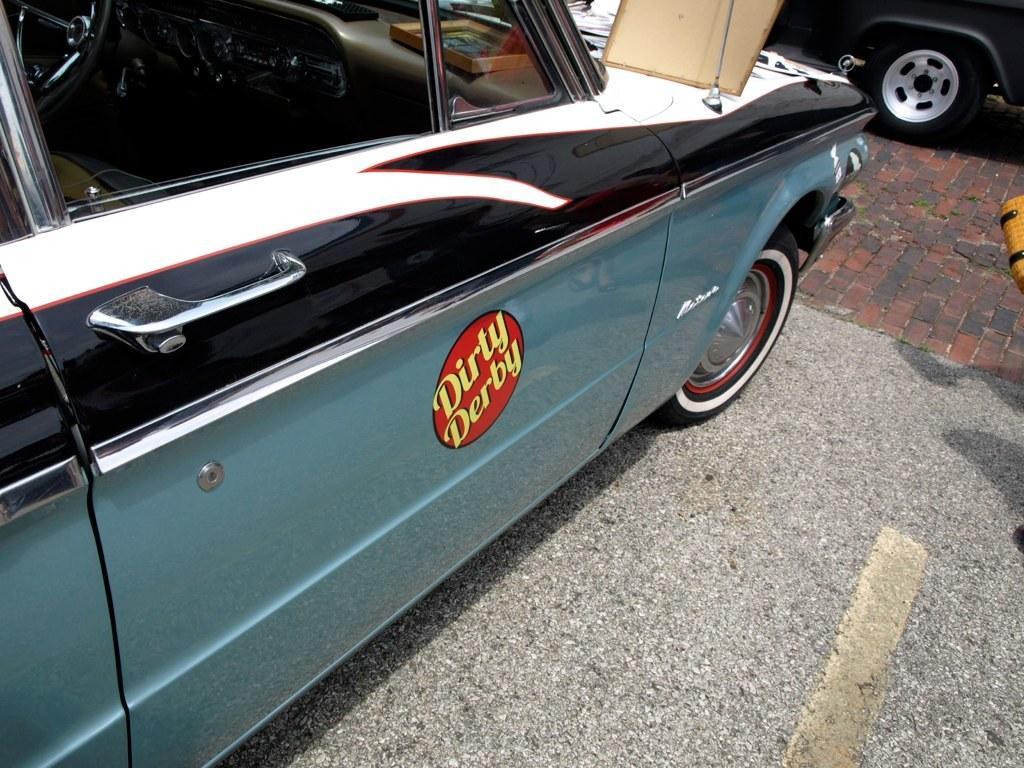Can you describe this image briefly? In this picture we can observe a car parked on the road. This is a blue and black color car. We can observe yellow color words on the red color background on the door of the car. In the background there is another vehicle parked on the floor which is in black color. 